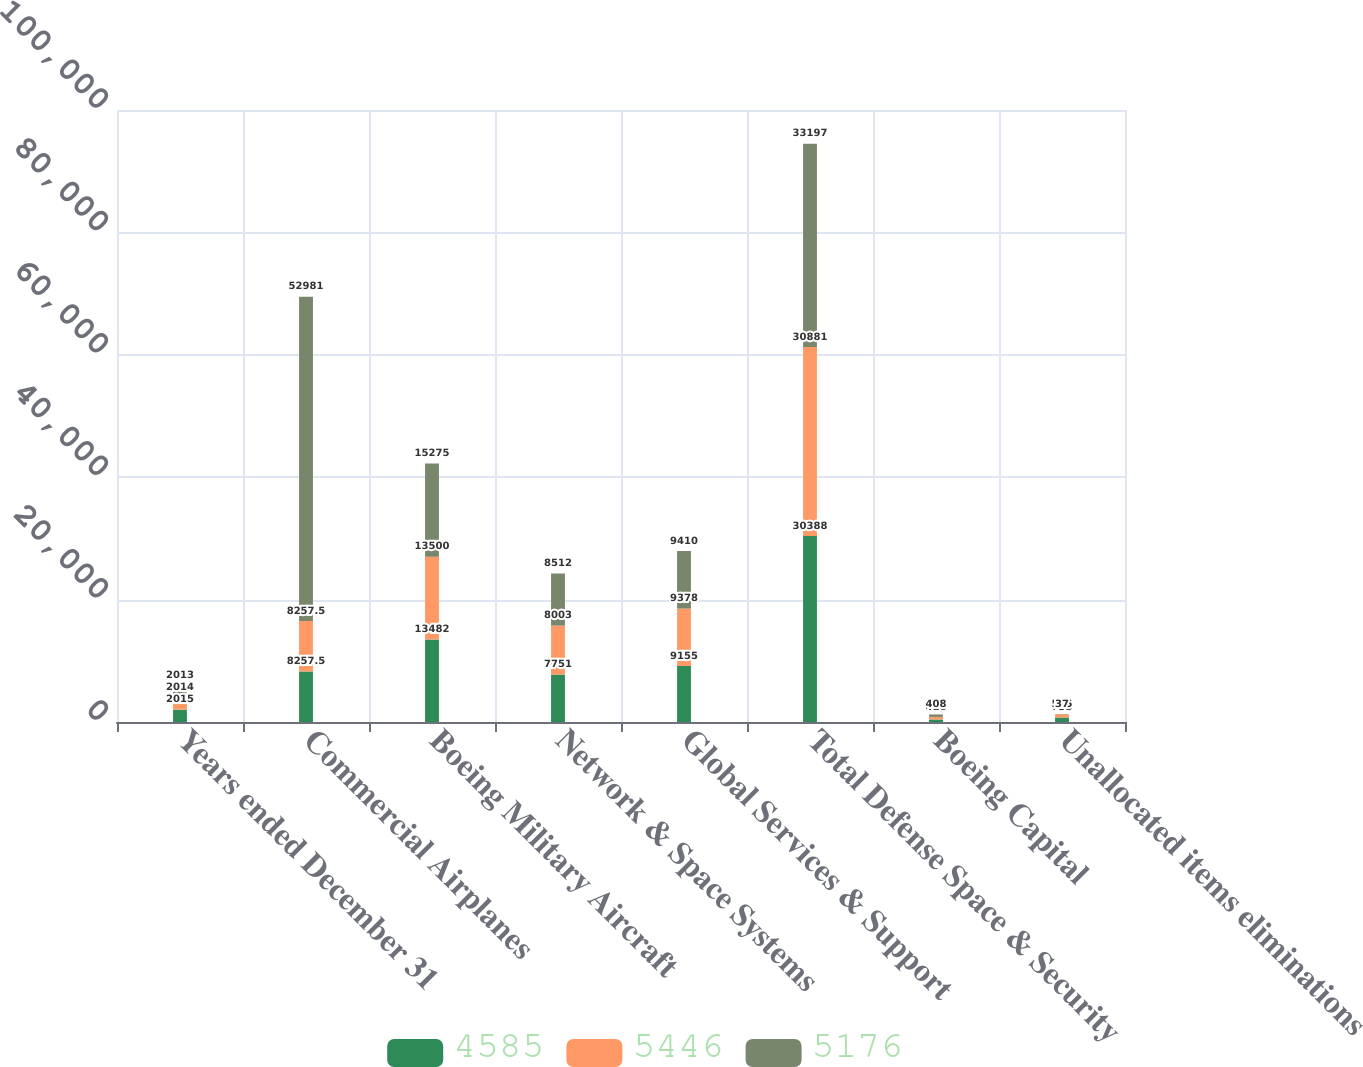<chart> <loc_0><loc_0><loc_500><loc_500><stacked_bar_chart><ecel><fcel>Years ended December 31<fcel>Commercial Airplanes<fcel>Boeing Military Aircraft<fcel>Network & Space Systems<fcel>Global Services & Support<fcel>Total Defense Space & Security<fcel>Boeing Capital<fcel>Unallocated items eliminations<nl><fcel>4585<fcel>2015<fcel>8257.5<fcel>13482<fcel>7751<fcel>9155<fcel>30388<fcel>413<fcel>735<nl><fcel>5446<fcel>2014<fcel>8257.5<fcel>13500<fcel>8003<fcel>9378<fcel>30881<fcel>416<fcel>525<nl><fcel>5176<fcel>2013<fcel>52981<fcel>15275<fcel>8512<fcel>9410<fcel>33197<fcel>408<fcel>37<nl></chart> 